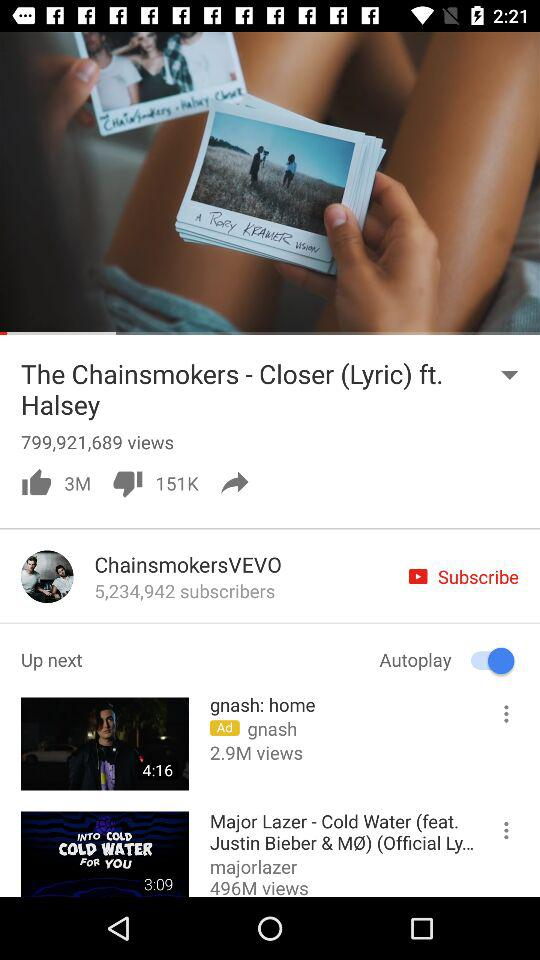What is the duration of "gnash: home"? The duration is 4 minutes and 16 seconds. 